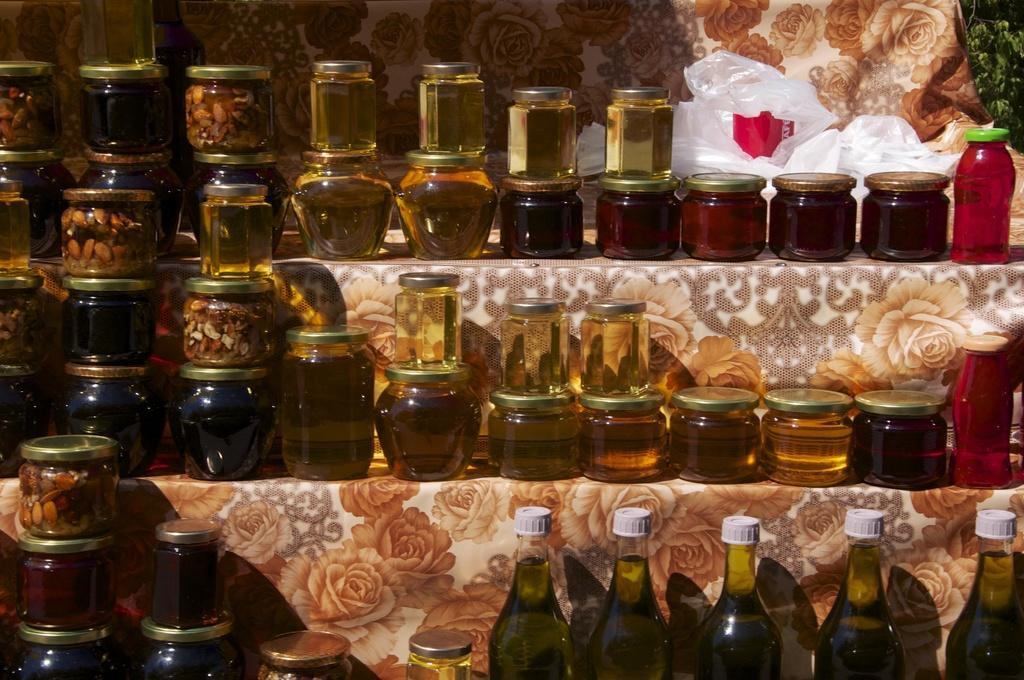In one or two sentences, can you explain what this image depicts? This picture shows glass bottles and few jars with some liquids and it 